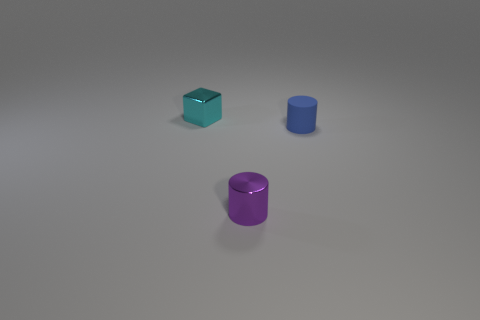How many balls are either small cyan things or purple objects?
Provide a succinct answer. 0. How many objects are either purple cylinders or rubber things?
Your answer should be compact. 2. What is the shape of the tiny cyan object?
Keep it short and to the point. Cube. Is there any other thing that has the same material as the blue cylinder?
Make the answer very short. No. There is a object that is in front of the cylinder on the right side of the tiny purple shiny object; how big is it?
Offer a very short reply. Small. Are there an equal number of cylinders in front of the small blue cylinder and tiny blue things?
Keep it short and to the point. Yes. What number of other things are there of the same color as the metal cube?
Your answer should be compact. 0. Is the number of tiny blocks in front of the shiny cylinder less than the number of blue cylinders?
Offer a very short reply. Yes. Are there any other cubes of the same size as the cyan cube?
Your answer should be compact. No. There is a cylinder that is left of the blue thing; what number of small shiny things are on the left side of it?
Offer a very short reply. 1. 